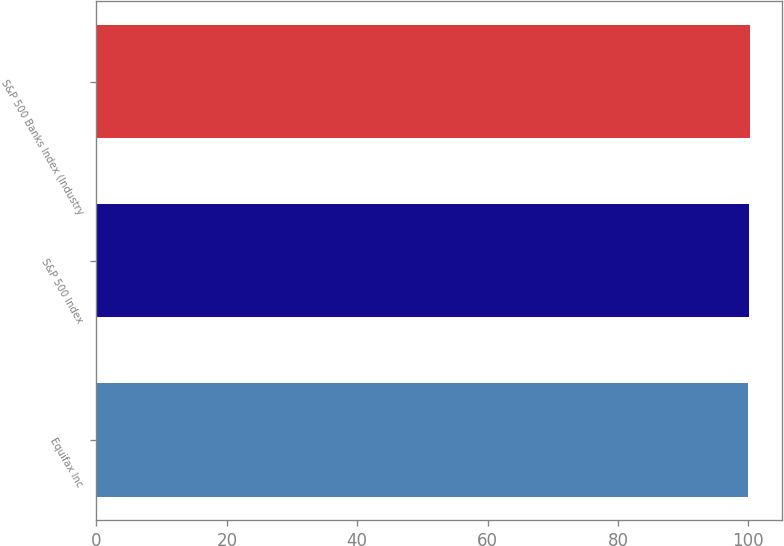Convert chart to OTSL. <chart><loc_0><loc_0><loc_500><loc_500><bar_chart><fcel>Equifax Inc<fcel>S&P 500 Index<fcel>S&P 500 Banks Index (Industry<nl><fcel>100<fcel>100.1<fcel>100.2<nl></chart> 